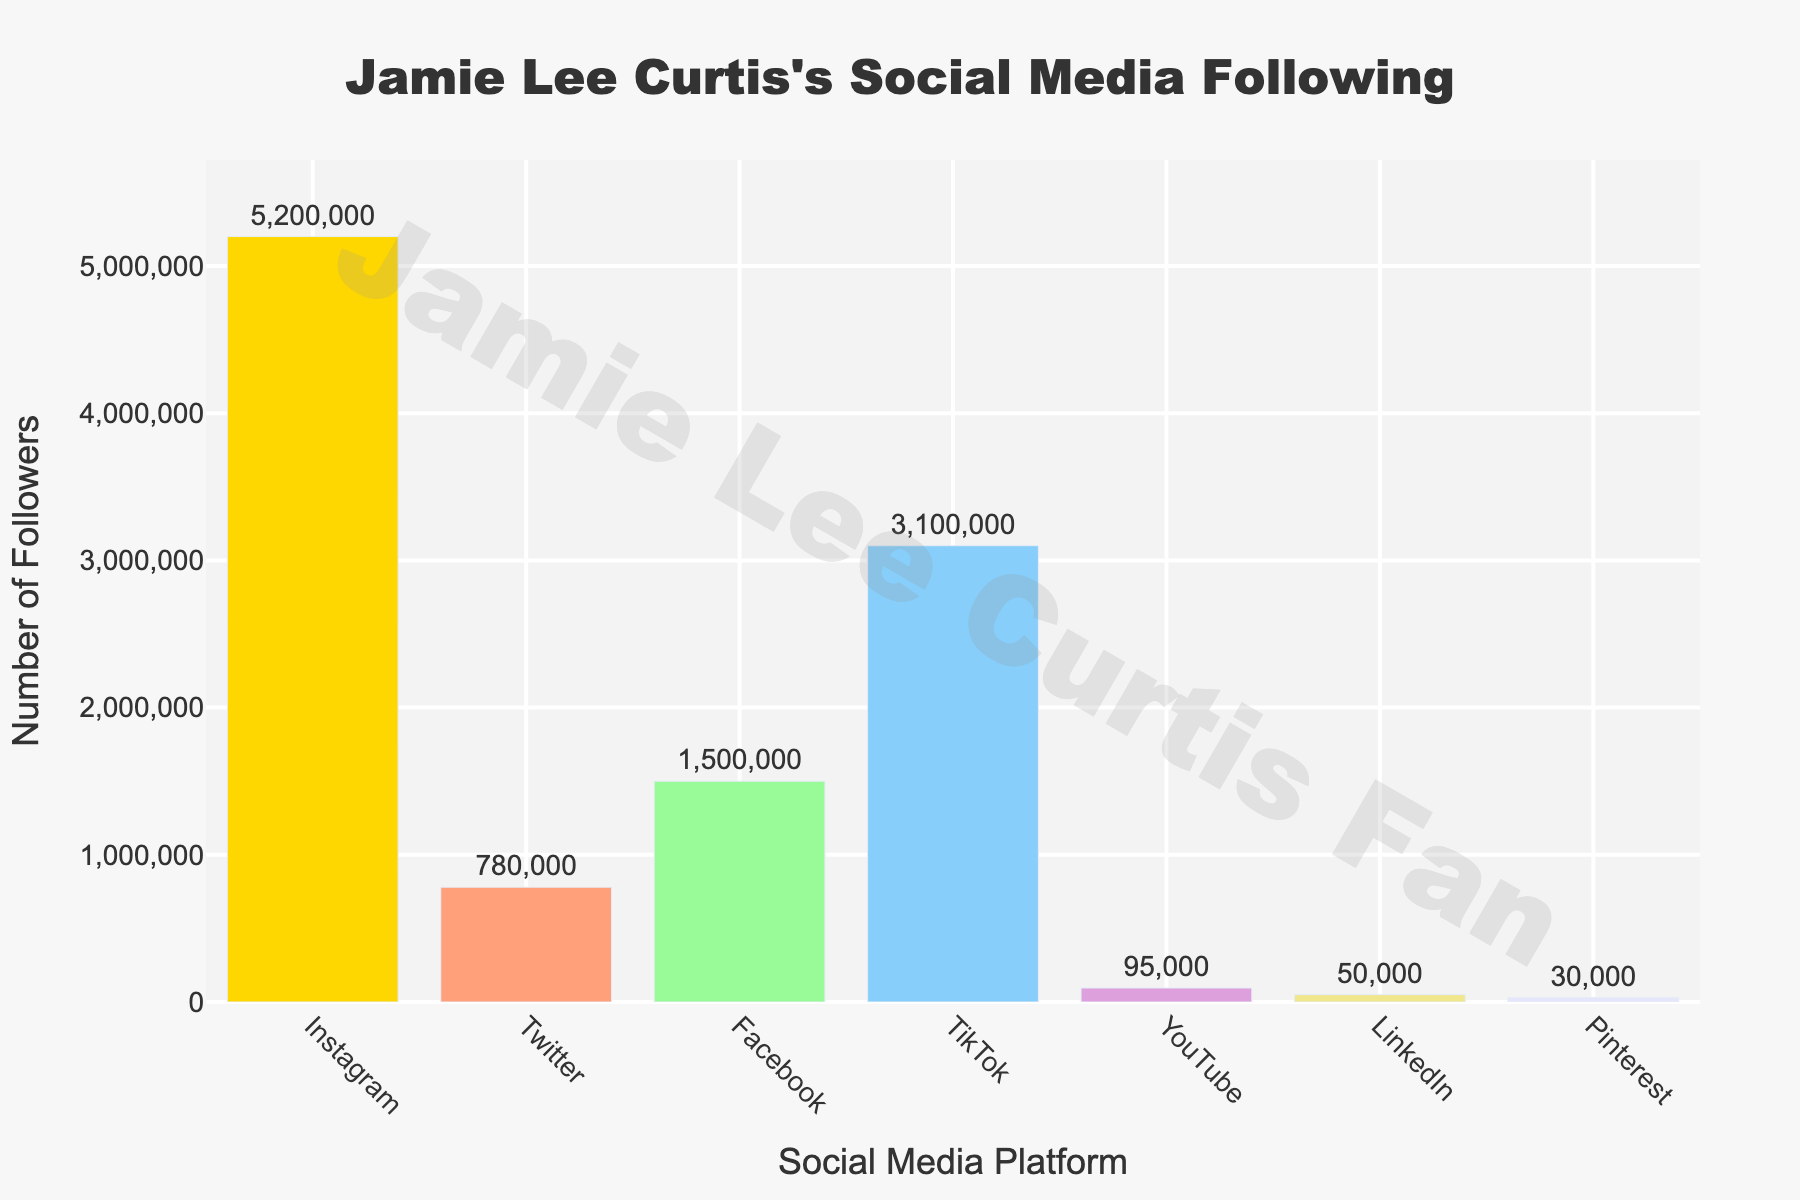Which social media platform has the highest follower count? The bar representing Instagram is the tallest, indicating it has the highest follower count.
Answer: Instagram Which platform has fewer followers, Twitter or YouTube? Compare the heights of the bars for Twitter and YouTube. The bar for YouTube is shorter than the bar for Twitter.
Answer: YouTube What is the total number of followers across all platforms? Sum the follower counts of all platforms: 5,200,000 (Instagram) + 780,000 (Twitter) + 1,500,000 (Facebook) + 3,100,000 (TikTok) + 95,000 (YouTube) + 50,000 (LinkedIn) + 30,000 (Pinterest). The total is 10,755,000.
Answer: 10,755,000 How many more followers does Instagram have compared to Facebook? Subtract the follower count of Facebook from Instagram: 5,200,000 - 1,500,000 = 3,700,000.
Answer: 3,700,000 Which platform has the second lowest follower count? Arrange the platforms in ascending order of followers: Pinterest (30,000), LinkedIn (50,000), YouTube (95,000), Twitter (780,000), Facebook (1,500,000), TikTok (3,100,000), Instagram (5,200,000). LinkedIn has the second lowest count.
Answer: LinkedIn Are there more followers on Instagram and TikTok combined than the total followers on all other platforms? Calculate combined followers for Instagram and TikTok: 5,200,000 + 3,100,000 = 8,300,000. Calculate total followers on all other platforms: 10,755,000 - 8,300,000 = 2,455,000. Compare: 8,300,000 > 2,455,000.
Answer: Yes Which platforms have fewer than one million followers? Identify bars shorter than one million followers: Twitter (780,000), YouTube (95,000), LinkedIn (50,000), and Pinterest (30,000).
Answer: Twitter, YouTube, LinkedIn, Pinterest By how much do Facebook followers exceed YouTube followers? Subtract the follower count of YouTube from Facebook: 1,500,000 - 95,000 = 1,405,000.
Answer: 1,405,000 What is the average number of followers across all platforms? Calculate total followers and divide by the number of platforms: 10,755,000 / 7 = 1,536,428.57.
Answer: 1,536,429 